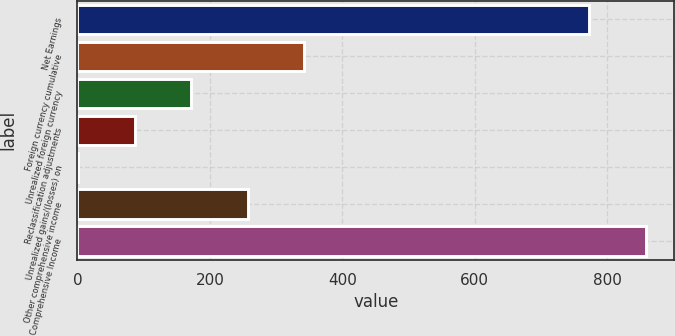Convert chart. <chart><loc_0><loc_0><loc_500><loc_500><bar_chart><fcel>Net Earnings<fcel>Foreign currency cumulative<fcel>Unrealized foreign currency<fcel>Reclassification adjustments<fcel>Unrealized gains/(losses) on<fcel>Other comprehensive income<fcel>Comprehensive Income<nl><fcel>773.2<fcel>342.56<fcel>171.98<fcel>86.69<fcel>1.4<fcel>257.27<fcel>858.49<nl></chart> 